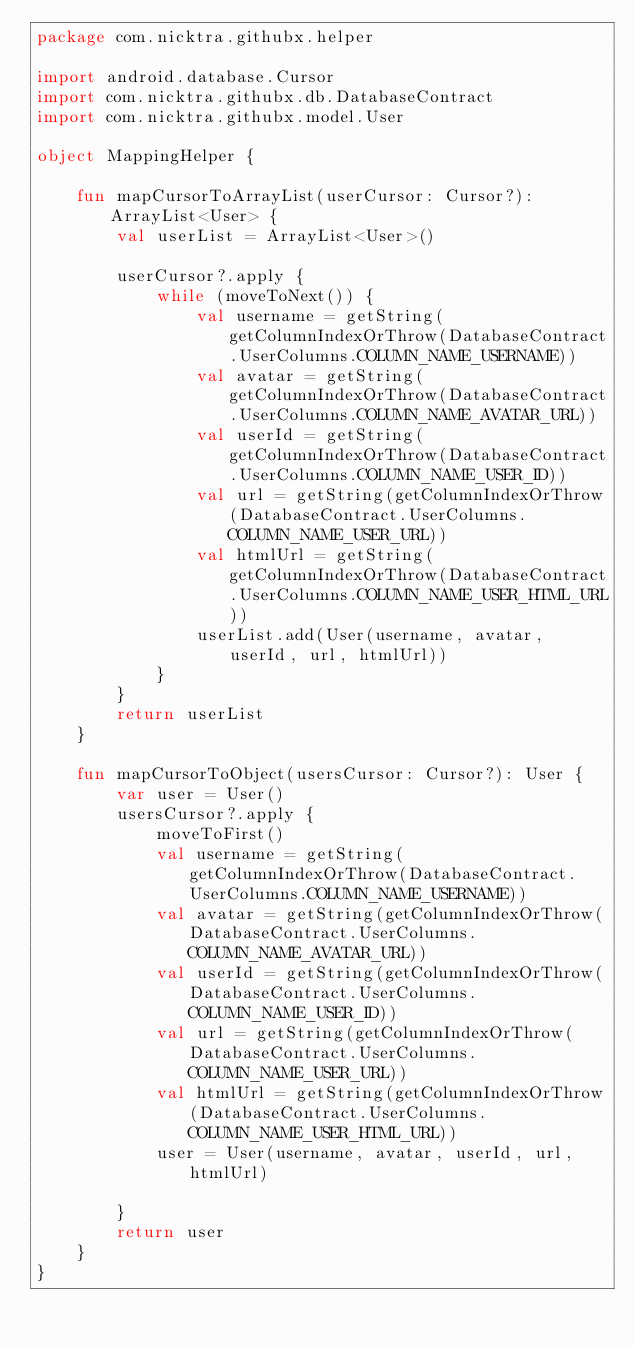Convert code to text. <code><loc_0><loc_0><loc_500><loc_500><_Kotlin_>package com.nicktra.githubx.helper

import android.database.Cursor
import com.nicktra.githubx.db.DatabaseContract
import com.nicktra.githubx.model.User

object MappingHelper {

    fun mapCursorToArrayList(userCursor: Cursor?): ArrayList<User> {
        val userList = ArrayList<User>()

        userCursor?.apply {
            while (moveToNext()) {
                val username = getString(getColumnIndexOrThrow(DatabaseContract.UserColumns.COLUMN_NAME_USERNAME))
                val avatar = getString(getColumnIndexOrThrow(DatabaseContract.UserColumns.COLUMN_NAME_AVATAR_URL))
                val userId = getString(getColumnIndexOrThrow(DatabaseContract.UserColumns.COLUMN_NAME_USER_ID))
                val url = getString(getColumnIndexOrThrow(DatabaseContract.UserColumns.COLUMN_NAME_USER_URL))
                val htmlUrl = getString(getColumnIndexOrThrow(DatabaseContract.UserColumns.COLUMN_NAME_USER_HTML_URL))
                userList.add(User(username, avatar, userId, url, htmlUrl))
            }
        }
        return userList
    }

    fun mapCursorToObject(usersCursor: Cursor?): User {
        var user = User()
        usersCursor?.apply {
            moveToFirst()
            val username = getString(getColumnIndexOrThrow(DatabaseContract.UserColumns.COLUMN_NAME_USERNAME))
            val avatar = getString(getColumnIndexOrThrow(DatabaseContract.UserColumns.COLUMN_NAME_AVATAR_URL))
            val userId = getString(getColumnIndexOrThrow(DatabaseContract.UserColumns.COLUMN_NAME_USER_ID))
            val url = getString(getColumnIndexOrThrow(DatabaseContract.UserColumns.COLUMN_NAME_USER_URL))
            val htmlUrl = getString(getColumnIndexOrThrow(DatabaseContract.UserColumns.COLUMN_NAME_USER_HTML_URL))
            user = User(username, avatar, userId, url, htmlUrl)

        }
        return user
    }
}</code> 